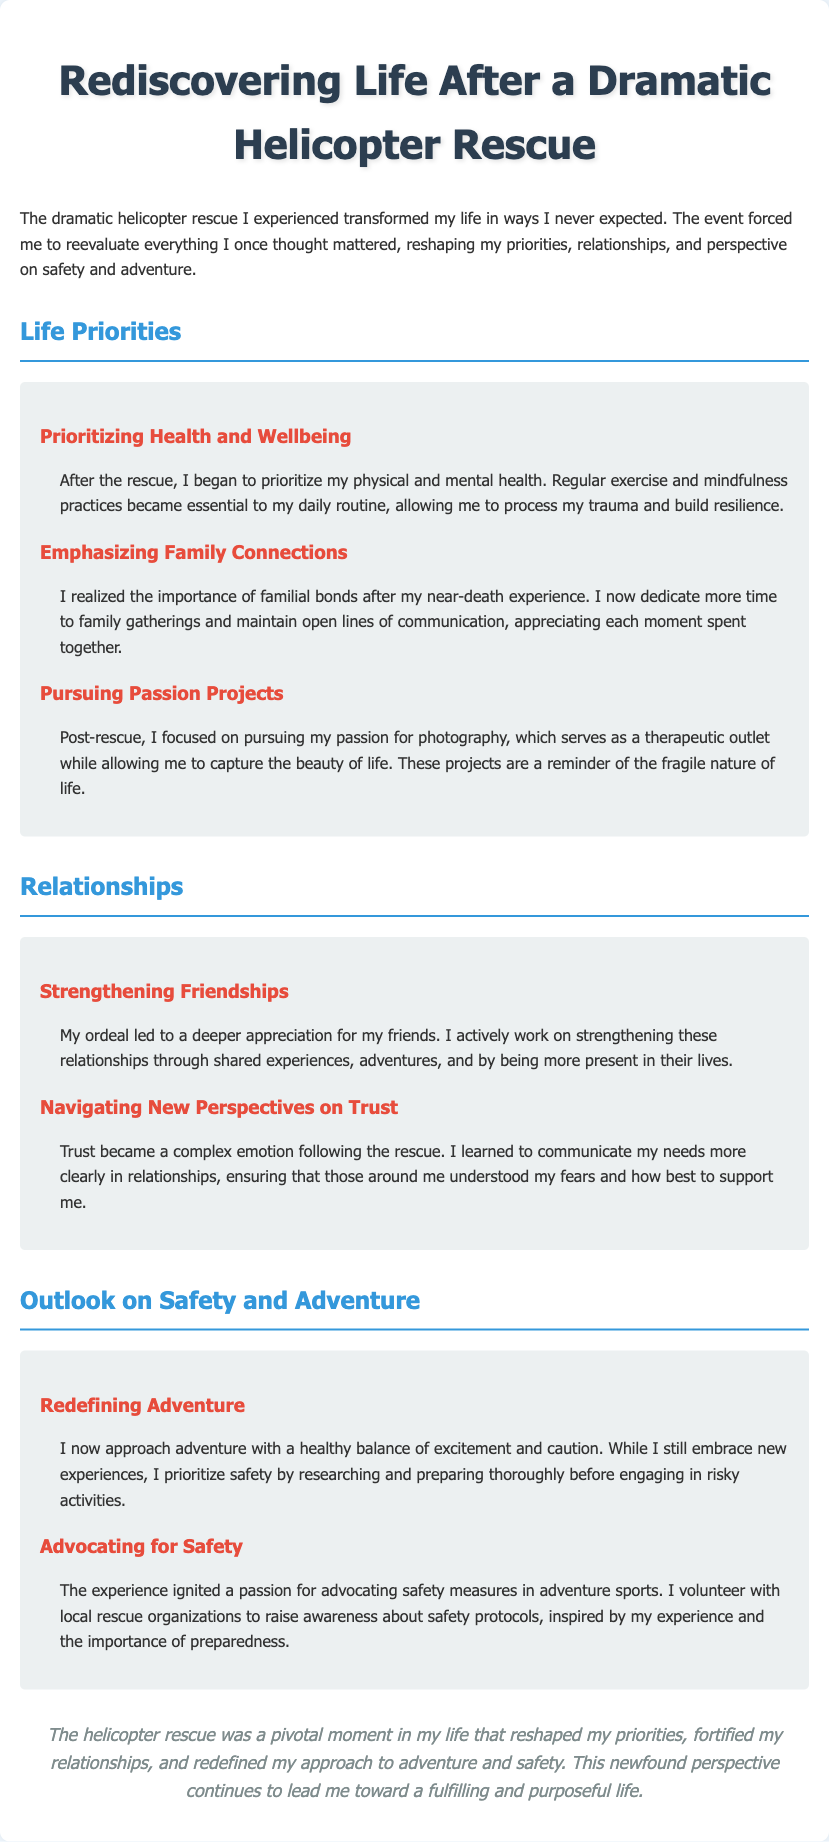What is the title of the document? The title is presented prominently at the top of the document, which is "Rediscovering Life After a Dramatic Helicopter Rescue."
Answer: Rediscovering Life After a Dramatic Helicopter Rescue What are the two main sections of personal impact described in the document? The document emphasizes "Life Priorities" and "Relationships" as the main sections of personal impact post-rescue.
Answer: Life Priorities, Relationships What therapeutic outlet does the author pursue? The author discusses pursuing photography as a way to process emotions and capture beauty, which serves as a therapeutic outlet.
Answer: Photography What is a new approach to adventure mentioned in the document? The document states that the author now approaches adventure with a combination of excitement and caution, prioritizing safety.
Answer: Excitement and caution How has family interaction changed after the rescue? The document indicates that the author now dedicates more time to family gatherings and maintains open lines of communication.
Answer: More time to family gatherings What new activity is the author involved in to promote safety? The author is involved in advocating for safety measures in adventure sports and volunteers with local rescue organizations.
Answer: Advocating for safety What is the significance of the helicopter rescue in the author's life? The author describes the rescue as a pivotal moment that reshaped their priorities, fortified relationships, and redefined adventure.
Answer: A pivotal moment What practice became essential for the author after the rescue? The document mentions that regular exercise and mindfulness practices became essential for the author's daily routine.
Answer: Regular exercise and mindfulness practices What emotion became complex following the rescue experience? Trust emerged as a complex emotion for the author after their near-death experience.
Answer: Trust 